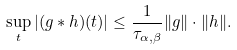<formula> <loc_0><loc_0><loc_500><loc_500>\sup _ { t } | ( g * h ) ( t ) | \leq \frac { 1 } { \tau _ { \alpha , \beta } } \| g \| \cdot \| h \| .</formula> 